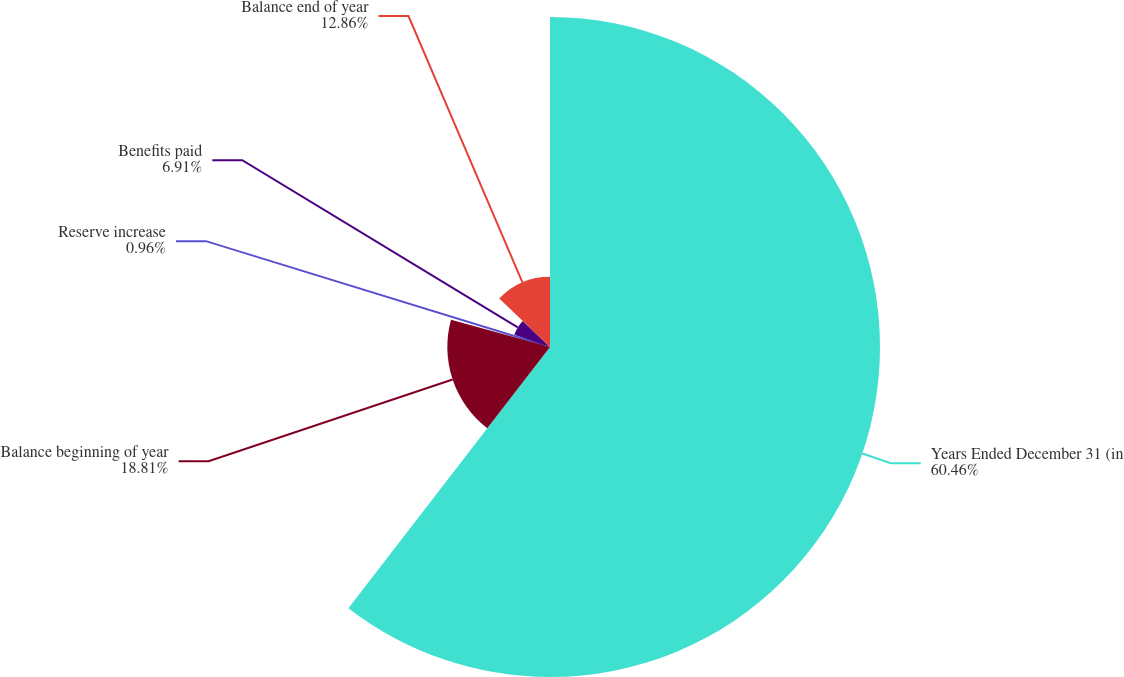Convert chart to OTSL. <chart><loc_0><loc_0><loc_500><loc_500><pie_chart><fcel>Years Ended December 31 (in<fcel>Balance beginning of year<fcel>Reserve increase<fcel>Benefits paid<fcel>Balance end of year<nl><fcel>60.46%<fcel>18.81%<fcel>0.96%<fcel>6.91%<fcel>12.86%<nl></chart> 